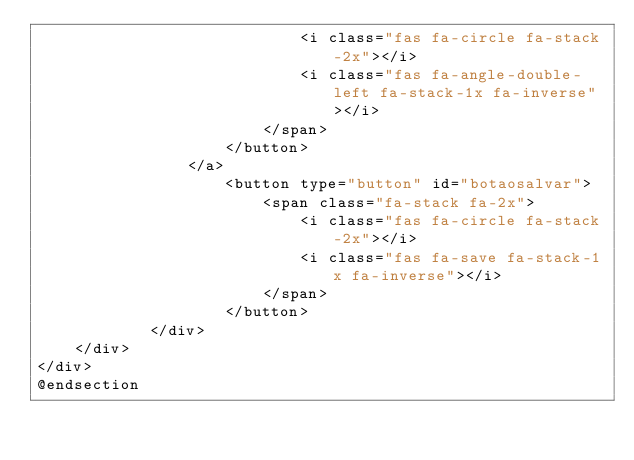Convert code to text. <code><loc_0><loc_0><loc_500><loc_500><_PHP_>                            <i class="fas fa-circle fa-stack-2x"></i>
                            <i class="fas fa-angle-double-left fa-stack-1x fa-inverse"></i>
                        </span>
                    </button>
                </a>
                    <button type="button" id="botaosalvar">
                        <span class="fa-stack fa-2x">
                            <i class="fas fa-circle fa-stack-2x"></i>
                            <i class="fas fa-save fa-stack-1x fa-inverse"></i>
                        </span>
                    </button>
            </div>
    </div>
</div>
@endsection
</code> 